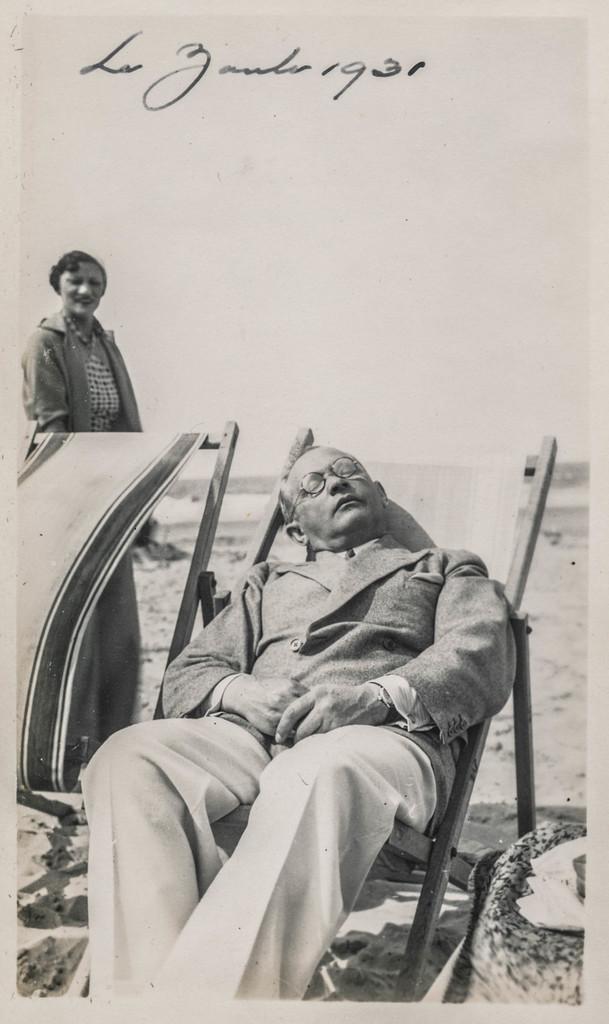In one or two sentences, can you explain what this image depicts? This picture might be a photo frame. This is a black and white image. In this image, in the middle, we can see a man lying on the chair. On the left side, we can also see another chair and person standing. In the background, we can see some text written on it, at the bottom, we can see a land. 